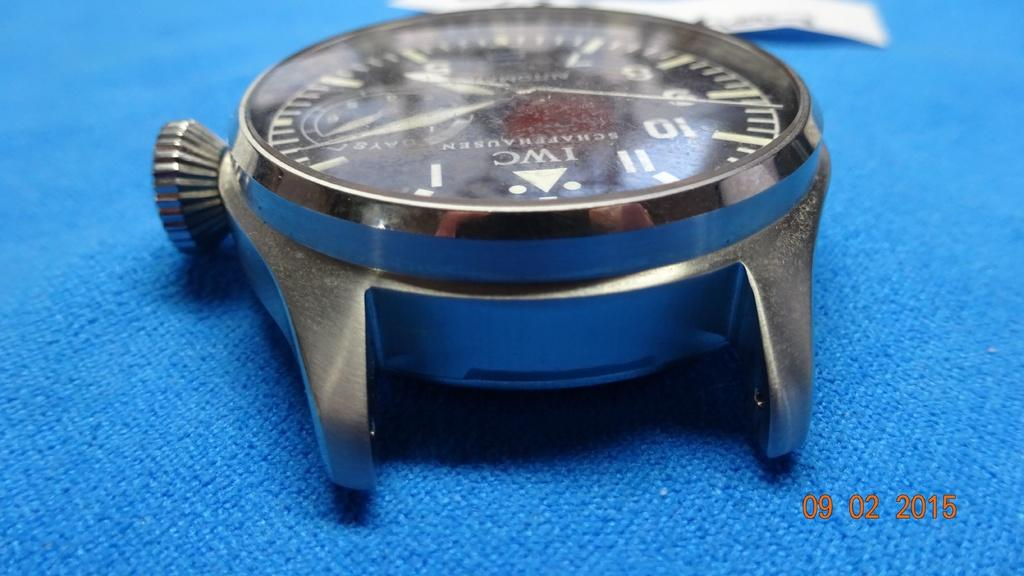<image>
Write a terse but informative summary of the picture. An IWC watch without a band sits on blue cloth. 